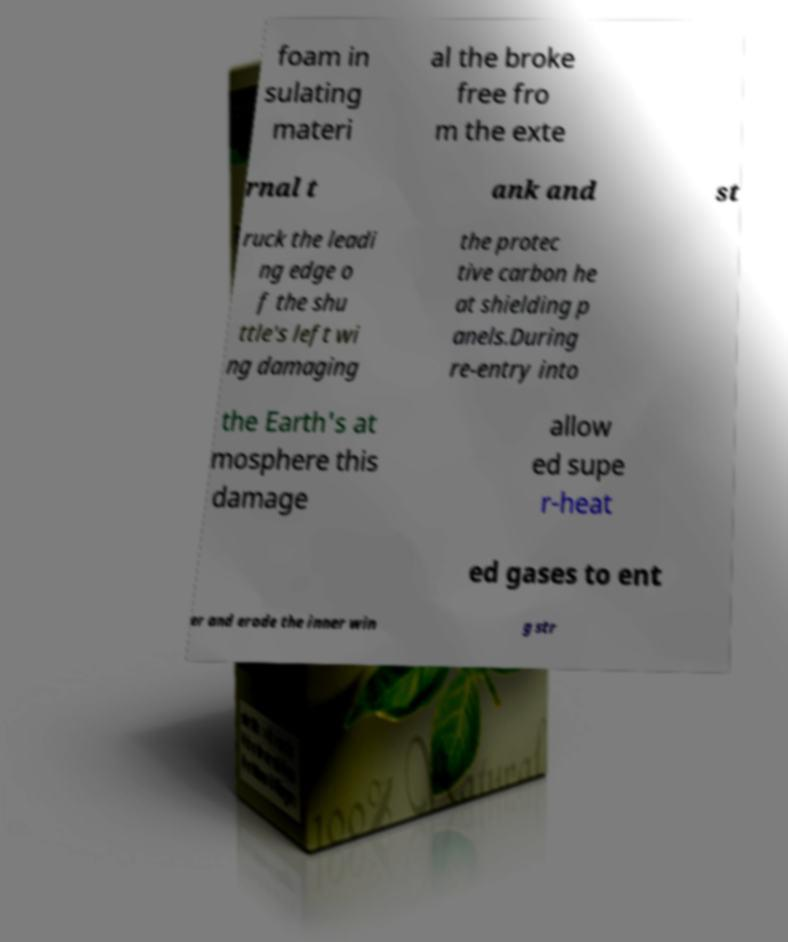Can you read and provide the text displayed in the image?This photo seems to have some interesting text. Can you extract and type it out for me? foam in sulating materi al the broke free fro m the exte rnal t ank and st ruck the leadi ng edge o f the shu ttle's left wi ng damaging the protec tive carbon he at shielding p anels.During re-entry into the Earth's at mosphere this damage allow ed supe r-heat ed gases to ent er and erode the inner win g str 